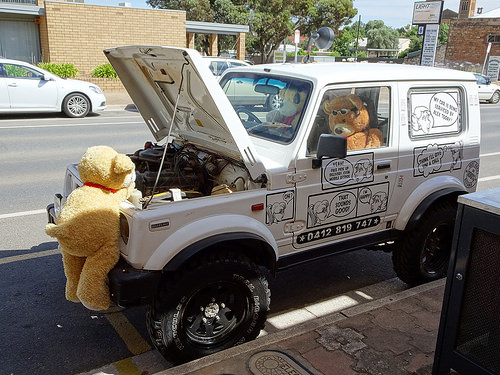<image>
Is the stuffed animal next to the car? Yes. The stuffed animal is positioned adjacent to the car, located nearby in the same general area. 